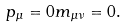Convert formula to latex. <formula><loc_0><loc_0><loc_500><loc_500>p _ { \mu } = 0 m _ { \mu \nu } = 0 .</formula> 